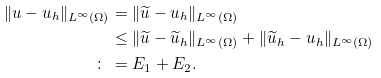<formula> <loc_0><loc_0><loc_500><loc_500>\| u - u _ { h } \| _ { L ^ { \infty } ( \Omega ) } & = \| \widetilde { u } - u _ { h } \| _ { L ^ { \infty } ( \Omega ) } \\ & \leq \| \widetilde { u } - \widetilde { u } _ { h } \| _ { L ^ { \infty } ( \Omega ) } + \| \widetilde { u } _ { h } - u _ { h } \| _ { L ^ { \infty } ( \Omega ) } \\ \colon \, & = E _ { 1 } + E _ { 2 } .</formula> 